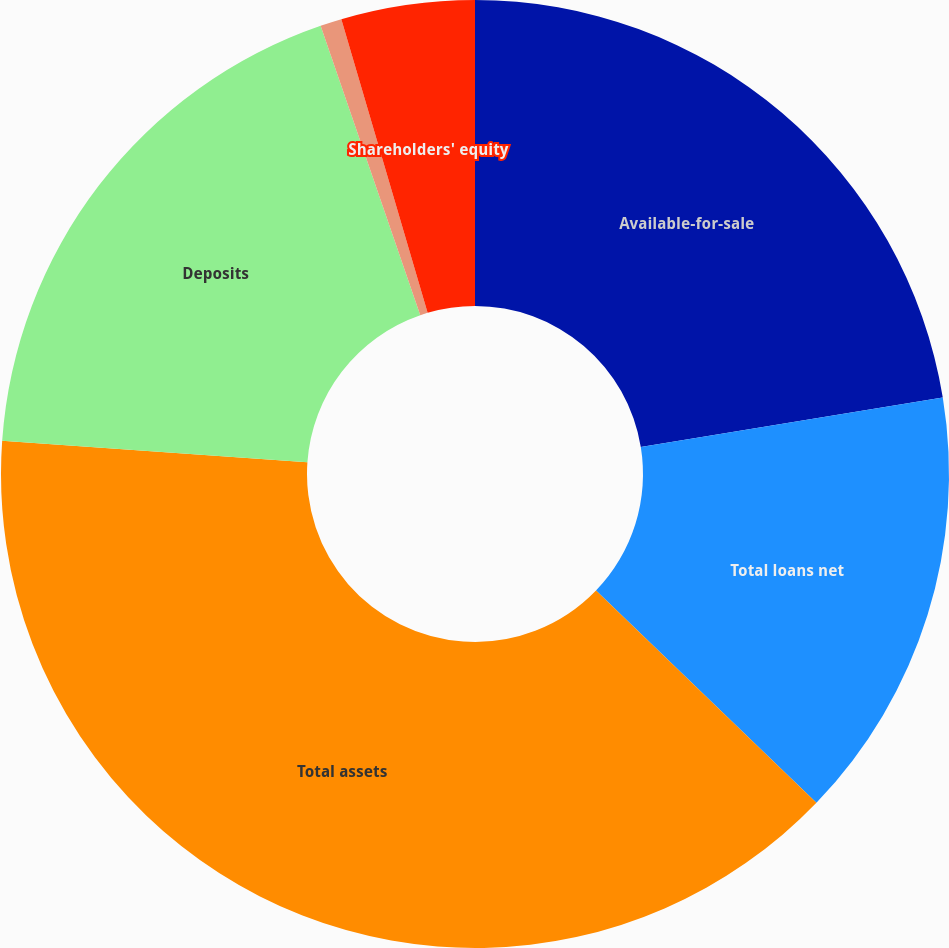Convert chart to OTSL. <chart><loc_0><loc_0><loc_500><loc_500><pie_chart><fcel>Available-for-sale<fcel>Total loans net<fcel>Total assets<fcel>Deposits<fcel>Corporate debt<fcel>Shareholders' equity<nl><fcel>22.42%<fcel>14.78%<fcel>38.92%<fcel>18.6%<fcel>0.73%<fcel>4.55%<nl></chart> 